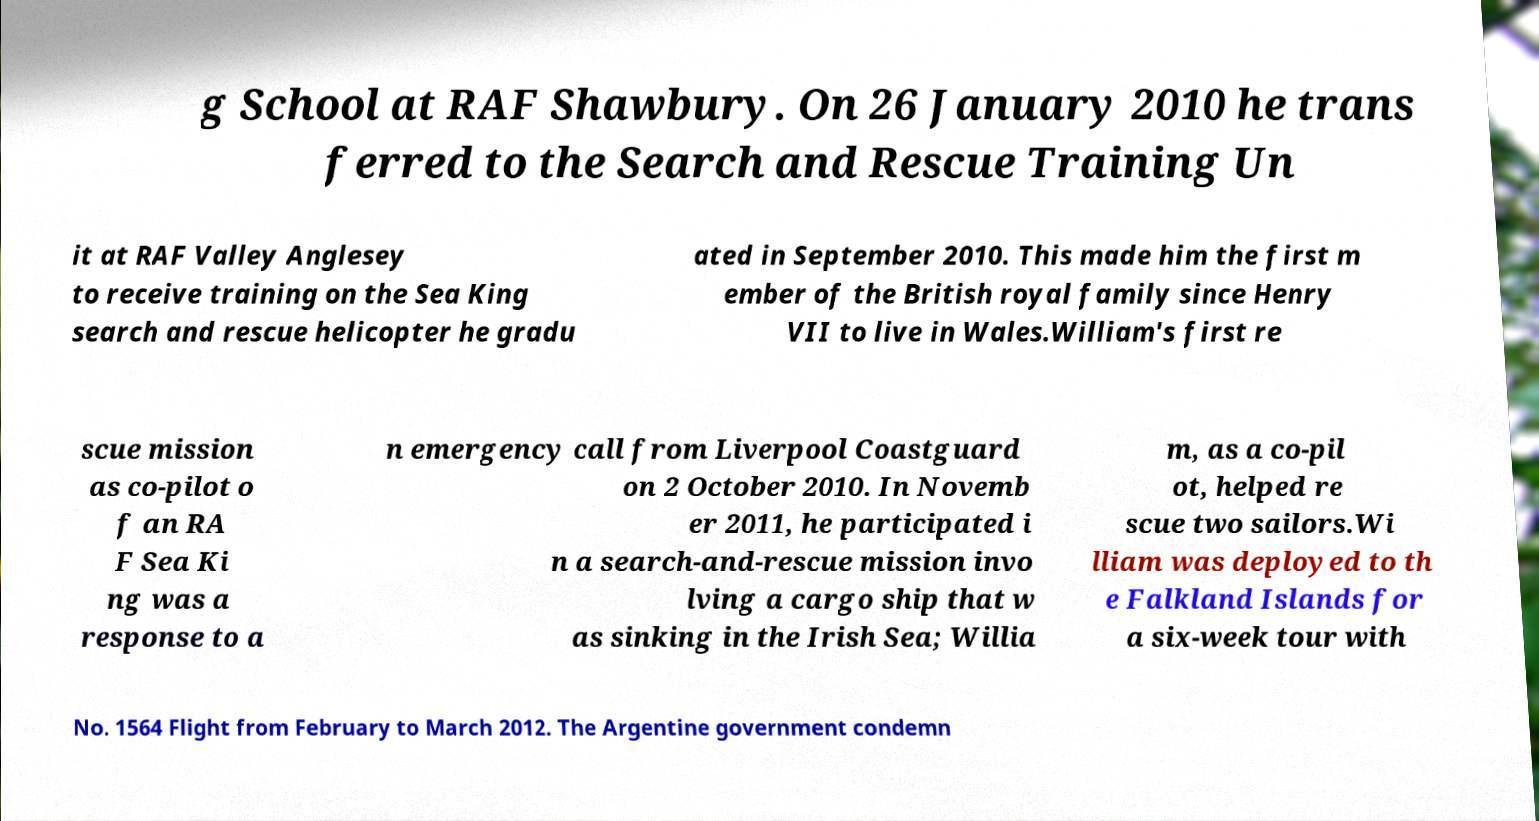Can you read and provide the text displayed in the image?This photo seems to have some interesting text. Can you extract and type it out for me? g School at RAF Shawbury. On 26 January 2010 he trans ferred to the Search and Rescue Training Un it at RAF Valley Anglesey to receive training on the Sea King search and rescue helicopter he gradu ated in September 2010. This made him the first m ember of the British royal family since Henry VII to live in Wales.William's first re scue mission as co-pilot o f an RA F Sea Ki ng was a response to a n emergency call from Liverpool Coastguard on 2 October 2010. In Novemb er 2011, he participated i n a search-and-rescue mission invo lving a cargo ship that w as sinking in the Irish Sea; Willia m, as a co-pil ot, helped re scue two sailors.Wi lliam was deployed to th e Falkland Islands for a six-week tour with No. 1564 Flight from February to March 2012. The Argentine government condemn 